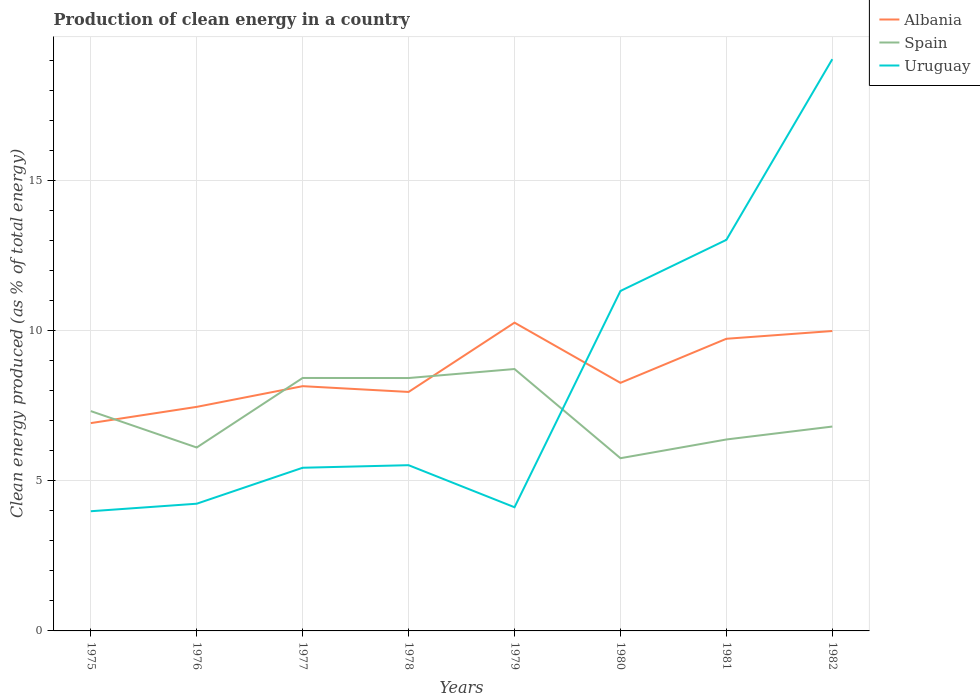How many different coloured lines are there?
Make the answer very short. 3. Does the line corresponding to Uruguay intersect with the line corresponding to Spain?
Offer a very short reply. Yes. Across all years, what is the maximum percentage of clean energy produced in Albania?
Give a very brief answer. 6.92. In which year was the percentage of clean energy produced in Uruguay maximum?
Offer a terse response. 1975. What is the total percentage of clean energy produced in Spain in the graph?
Keep it short and to the point. -1.1. What is the difference between the highest and the second highest percentage of clean energy produced in Spain?
Your response must be concise. 2.97. Is the percentage of clean energy produced in Albania strictly greater than the percentage of clean energy produced in Uruguay over the years?
Provide a succinct answer. No. What is the difference between two consecutive major ticks on the Y-axis?
Keep it short and to the point. 5. Are the values on the major ticks of Y-axis written in scientific E-notation?
Offer a very short reply. No. What is the title of the graph?
Offer a terse response. Production of clean energy in a country. Does "Euro area" appear as one of the legend labels in the graph?
Provide a succinct answer. No. What is the label or title of the X-axis?
Keep it short and to the point. Years. What is the label or title of the Y-axis?
Offer a very short reply. Clean energy produced (as % of total energy). What is the Clean energy produced (as % of total energy) of Albania in 1975?
Keep it short and to the point. 6.92. What is the Clean energy produced (as % of total energy) in Spain in 1975?
Provide a succinct answer. 7.32. What is the Clean energy produced (as % of total energy) of Uruguay in 1975?
Make the answer very short. 3.98. What is the Clean energy produced (as % of total energy) in Albania in 1976?
Give a very brief answer. 7.46. What is the Clean energy produced (as % of total energy) of Spain in 1976?
Your answer should be very brief. 6.11. What is the Clean energy produced (as % of total energy) in Uruguay in 1976?
Keep it short and to the point. 4.24. What is the Clean energy produced (as % of total energy) of Albania in 1977?
Your answer should be very brief. 8.15. What is the Clean energy produced (as % of total energy) in Spain in 1977?
Provide a short and direct response. 8.42. What is the Clean energy produced (as % of total energy) of Uruguay in 1977?
Your answer should be very brief. 5.43. What is the Clean energy produced (as % of total energy) of Albania in 1978?
Your answer should be very brief. 7.96. What is the Clean energy produced (as % of total energy) in Spain in 1978?
Provide a succinct answer. 8.42. What is the Clean energy produced (as % of total energy) in Uruguay in 1978?
Provide a succinct answer. 5.52. What is the Clean energy produced (as % of total energy) of Albania in 1979?
Make the answer very short. 10.26. What is the Clean energy produced (as % of total energy) in Spain in 1979?
Provide a short and direct response. 8.72. What is the Clean energy produced (as % of total energy) of Uruguay in 1979?
Your response must be concise. 4.12. What is the Clean energy produced (as % of total energy) of Albania in 1980?
Provide a short and direct response. 8.26. What is the Clean energy produced (as % of total energy) in Spain in 1980?
Your response must be concise. 5.75. What is the Clean energy produced (as % of total energy) in Uruguay in 1980?
Offer a very short reply. 11.32. What is the Clean energy produced (as % of total energy) of Albania in 1981?
Ensure brevity in your answer.  9.73. What is the Clean energy produced (as % of total energy) in Spain in 1981?
Give a very brief answer. 6.37. What is the Clean energy produced (as % of total energy) of Uruguay in 1981?
Offer a terse response. 13.02. What is the Clean energy produced (as % of total energy) of Albania in 1982?
Provide a succinct answer. 9.99. What is the Clean energy produced (as % of total energy) of Spain in 1982?
Your answer should be very brief. 6.8. What is the Clean energy produced (as % of total energy) of Uruguay in 1982?
Provide a short and direct response. 19.04. Across all years, what is the maximum Clean energy produced (as % of total energy) of Albania?
Provide a succinct answer. 10.26. Across all years, what is the maximum Clean energy produced (as % of total energy) in Spain?
Offer a terse response. 8.72. Across all years, what is the maximum Clean energy produced (as % of total energy) of Uruguay?
Offer a very short reply. 19.04. Across all years, what is the minimum Clean energy produced (as % of total energy) of Albania?
Keep it short and to the point. 6.92. Across all years, what is the minimum Clean energy produced (as % of total energy) in Spain?
Make the answer very short. 5.75. Across all years, what is the minimum Clean energy produced (as % of total energy) of Uruguay?
Give a very brief answer. 3.98. What is the total Clean energy produced (as % of total energy) of Albania in the graph?
Provide a short and direct response. 68.72. What is the total Clean energy produced (as % of total energy) of Spain in the graph?
Your response must be concise. 57.92. What is the total Clean energy produced (as % of total energy) in Uruguay in the graph?
Offer a very short reply. 66.66. What is the difference between the Clean energy produced (as % of total energy) in Albania in 1975 and that in 1976?
Make the answer very short. -0.54. What is the difference between the Clean energy produced (as % of total energy) of Spain in 1975 and that in 1976?
Give a very brief answer. 1.21. What is the difference between the Clean energy produced (as % of total energy) in Uruguay in 1975 and that in 1976?
Your answer should be compact. -0.25. What is the difference between the Clean energy produced (as % of total energy) in Albania in 1975 and that in 1977?
Provide a succinct answer. -1.23. What is the difference between the Clean energy produced (as % of total energy) in Spain in 1975 and that in 1977?
Offer a terse response. -1.1. What is the difference between the Clean energy produced (as % of total energy) of Uruguay in 1975 and that in 1977?
Provide a succinct answer. -1.45. What is the difference between the Clean energy produced (as % of total energy) in Albania in 1975 and that in 1978?
Your response must be concise. -1.04. What is the difference between the Clean energy produced (as % of total energy) of Spain in 1975 and that in 1978?
Provide a succinct answer. -1.1. What is the difference between the Clean energy produced (as % of total energy) of Uruguay in 1975 and that in 1978?
Give a very brief answer. -1.53. What is the difference between the Clean energy produced (as % of total energy) of Albania in 1975 and that in 1979?
Give a very brief answer. -3.34. What is the difference between the Clean energy produced (as % of total energy) of Spain in 1975 and that in 1979?
Give a very brief answer. -1.4. What is the difference between the Clean energy produced (as % of total energy) of Uruguay in 1975 and that in 1979?
Your answer should be compact. -0.13. What is the difference between the Clean energy produced (as % of total energy) in Albania in 1975 and that in 1980?
Keep it short and to the point. -1.34. What is the difference between the Clean energy produced (as % of total energy) in Spain in 1975 and that in 1980?
Your response must be concise. 1.57. What is the difference between the Clean energy produced (as % of total energy) of Uruguay in 1975 and that in 1980?
Provide a short and direct response. -7.33. What is the difference between the Clean energy produced (as % of total energy) of Albania in 1975 and that in 1981?
Your response must be concise. -2.81. What is the difference between the Clean energy produced (as % of total energy) in Spain in 1975 and that in 1981?
Offer a very short reply. 0.94. What is the difference between the Clean energy produced (as % of total energy) of Uruguay in 1975 and that in 1981?
Offer a very short reply. -9.04. What is the difference between the Clean energy produced (as % of total energy) in Albania in 1975 and that in 1982?
Your answer should be compact. -3.07. What is the difference between the Clean energy produced (as % of total energy) of Spain in 1975 and that in 1982?
Keep it short and to the point. 0.51. What is the difference between the Clean energy produced (as % of total energy) of Uruguay in 1975 and that in 1982?
Provide a short and direct response. -15.05. What is the difference between the Clean energy produced (as % of total energy) of Albania in 1976 and that in 1977?
Your response must be concise. -0.69. What is the difference between the Clean energy produced (as % of total energy) of Spain in 1976 and that in 1977?
Offer a very short reply. -2.32. What is the difference between the Clean energy produced (as % of total energy) in Uruguay in 1976 and that in 1977?
Give a very brief answer. -1.2. What is the difference between the Clean energy produced (as % of total energy) in Albania in 1976 and that in 1978?
Your answer should be very brief. -0.5. What is the difference between the Clean energy produced (as % of total energy) of Spain in 1976 and that in 1978?
Your answer should be very brief. -2.31. What is the difference between the Clean energy produced (as % of total energy) in Uruguay in 1976 and that in 1978?
Ensure brevity in your answer.  -1.28. What is the difference between the Clean energy produced (as % of total energy) in Albania in 1976 and that in 1979?
Provide a short and direct response. -2.8. What is the difference between the Clean energy produced (as % of total energy) of Spain in 1976 and that in 1979?
Your response must be concise. -2.61. What is the difference between the Clean energy produced (as % of total energy) in Uruguay in 1976 and that in 1979?
Make the answer very short. 0.12. What is the difference between the Clean energy produced (as % of total energy) of Albania in 1976 and that in 1980?
Make the answer very short. -0.8. What is the difference between the Clean energy produced (as % of total energy) in Spain in 1976 and that in 1980?
Make the answer very short. 0.36. What is the difference between the Clean energy produced (as % of total energy) of Uruguay in 1976 and that in 1980?
Your answer should be very brief. -7.08. What is the difference between the Clean energy produced (as % of total energy) of Albania in 1976 and that in 1981?
Make the answer very short. -2.27. What is the difference between the Clean energy produced (as % of total energy) of Spain in 1976 and that in 1981?
Offer a very short reply. -0.27. What is the difference between the Clean energy produced (as % of total energy) in Uruguay in 1976 and that in 1981?
Provide a succinct answer. -8.78. What is the difference between the Clean energy produced (as % of total energy) of Albania in 1976 and that in 1982?
Your response must be concise. -2.53. What is the difference between the Clean energy produced (as % of total energy) in Spain in 1976 and that in 1982?
Give a very brief answer. -0.7. What is the difference between the Clean energy produced (as % of total energy) in Uruguay in 1976 and that in 1982?
Your answer should be very brief. -14.8. What is the difference between the Clean energy produced (as % of total energy) in Albania in 1977 and that in 1978?
Your answer should be compact. 0.19. What is the difference between the Clean energy produced (as % of total energy) of Spain in 1977 and that in 1978?
Offer a terse response. 0. What is the difference between the Clean energy produced (as % of total energy) of Uruguay in 1977 and that in 1978?
Provide a short and direct response. -0.09. What is the difference between the Clean energy produced (as % of total energy) of Albania in 1977 and that in 1979?
Provide a succinct answer. -2.12. What is the difference between the Clean energy produced (as % of total energy) in Spain in 1977 and that in 1979?
Offer a very short reply. -0.3. What is the difference between the Clean energy produced (as % of total energy) of Uruguay in 1977 and that in 1979?
Keep it short and to the point. 1.31. What is the difference between the Clean energy produced (as % of total energy) in Albania in 1977 and that in 1980?
Give a very brief answer. -0.11. What is the difference between the Clean energy produced (as % of total energy) in Spain in 1977 and that in 1980?
Offer a terse response. 2.67. What is the difference between the Clean energy produced (as % of total energy) in Uruguay in 1977 and that in 1980?
Make the answer very short. -5.89. What is the difference between the Clean energy produced (as % of total energy) of Albania in 1977 and that in 1981?
Keep it short and to the point. -1.58. What is the difference between the Clean energy produced (as % of total energy) of Spain in 1977 and that in 1981?
Keep it short and to the point. 2.05. What is the difference between the Clean energy produced (as % of total energy) of Uruguay in 1977 and that in 1981?
Keep it short and to the point. -7.59. What is the difference between the Clean energy produced (as % of total energy) of Albania in 1977 and that in 1982?
Offer a very short reply. -1.84. What is the difference between the Clean energy produced (as % of total energy) of Spain in 1977 and that in 1982?
Make the answer very short. 1.62. What is the difference between the Clean energy produced (as % of total energy) in Uruguay in 1977 and that in 1982?
Your answer should be compact. -13.6. What is the difference between the Clean energy produced (as % of total energy) in Albania in 1978 and that in 1979?
Your response must be concise. -2.31. What is the difference between the Clean energy produced (as % of total energy) in Spain in 1978 and that in 1979?
Your answer should be compact. -0.3. What is the difference between the Clean energy produced (as % of total energy) in Uruguay in 1978 and that in 1979?
Your answer should be very brief. 1.4. What is the difference between the Clean energy produced (as % of total energy) of Albania in 1978 and that in 1980?
Give a very brief answer. -0.3. What is the difference between the Clean energy produced (as % of total energy) in Spain in 1978 and that in 1980?
Provide a short and direct response. 2.67. What is the difference between the Clean energy produced (as % of total energy) of Uruguay in 1978 and that in 1980?
Provide a succinct answer. -5.8. What is the difference between the Clean energy produced (as % of total energy) in Albania in 1978 and that in 1981?
Keep it short and to the point. -1.77. What is the difference between the Clean energy produced (as % of total energy) in Spain in 1978 and that in 1981?
Offer a terse response. 2.05. What is the difference between the Clean energy produced (as % of total energy) of Uruguay in 1978 and that in 1981?
Give a very brief answer. -7.5. What is the difference between the Clean energy produced (as % of total energy) of Albania in 1978 and that in 1982?
Offer a terse response. -2.03. What is the difference between the Clean energy produced (as % of total energy) in Spain in 1978 and that in 1982?
Your answer should be compact. 1.62. What is the difference between the Clean energy produced (as % of total energy) in Uruguay in 1978 and that in 1982?
Offer a terse response. -13.52. What is the difference between the Clean energy produced (as % of total energy) in Albania in 1979 and that in 1980?
Offer a very short reply. 2. What is the difference between the Clean energy produced (as % of total energy) in Spain in 1979 and that in 1980?
Your answer should be very brief. 2.97. What is the difference between the Clean energy produced (as % of total energy) of Uruguay in 1979 and that in 1980?
Offer a terse response. -7.2. What is the difference between the Clean energy produced (as % of total energy) in Albania in 1979 and that in 1981?
Keep it short and to the point. 0.54. What is the difference between the Clean energy produced (as % of total energy) of Spain in 1979 and that in 1981?
Provide a succinct answer. 2.35. What is the difference between the Clean energy produced (as % of total energy) in Uruguay in 1979 and that in 1981?
Your answer should be compact. -8.9. What is the difference between the Clean energy produced (as % of total energy) of Albania in 1979 and that in 1982?
Your answer should be compact. 0.28. What is the difference between the Clean energy produced (as % of total energy) of Spain in 1979 and that in 1982?
Offer a very short reply. 1.92. What is the difference between the Clean energy produced (as % of total energy) of Uruguay in 1979 and that in 1982?
Your answer should be compact. -14.92. What is the difference between the Clean energy produced (as % of total energy) of Albania in 1980 and that in 1981?
Offer a very short reply. -1.47. What is the difference between the Clean energy produced (as % of total energy) of Spain in 1980 and that in 1981?
Your response must be concise. -0.62. What is the difference between the Clean energy produced (as % of total energy) of Uruguay in 1980 and that in 1981?
Offer a very short reply. -1.7. What is the difference between the Clean energy produced (as % of total energy) in Albania in 1980 and that in 1982?
Keep it short and to the point. -1.73. What is the difference between the Clean energy produced (as % of total energy) of Spain in 1980 and that in 1982?
Keep it short and to the point. -1.05. What is the difference between the Clean energy produced (as % of total energy) in Uruguay in 1980 and that in 1982?
Provide a succinct answer. -7.72. What is the difference between the Clean energy produced (as % of total energy) in Albania in 1981 and that in 1982?
Make the answer very short. -0.26. What is the difference between the Clean energy produced (as % of total energy) of Spain in 1981 and that in 1982?
Make the answer very short. -0.43. What is the difference between the Clean energy produced (as % of total energy) of Uruguay in 1981 and that in 1982?
Provide a short and direct response. -6.02. What is the difference between the Clean energy produced (as % of total energy) in Albania in 1975 and the Clean energy produced (as % of total energy) in Spain in 1976?
Keep it short and to the point. 0.81. What is the difference between the Clean energy produced (as % of total energy) in Albania in 1975 and the Clean energy produced (as % of total energy) in Uruguay in 1976?
Your answer should be very brief. 2.68. What is the difference between the Clean energy produced (as % of total energy) of Spain in 1975 and the Clean energy produced (as % of total energy) of Uruguay in 1976?
Keep it short and to the point. 3.08. What is the difference between the Clean energy produced (as % of total energy) in Albania in 1975 and the Clean energy produced (as % of total energy) in Spain in 1977?
Give a very brief answer. -1.5. What is the difference between the Clean energy produced (as % of total energy) of Albania in 1975 and the Clean energy produced (as % of total energy) of Uruguay in 1977?
Ensure brevity in your answer.  1.49. What is the difference between the Clean energy produced (as % of total energy) in Spain in 1975 and the Clean energy produced (as % of total energy) in Uruguay in 1977?
Offer a terse response. 1.89. What is the difference between the Clean energy produced (as % of total energy) in Albania in 1975 and the Clean energy produced (as % of total energy) in Spain in 1978?
Your answer should be compact. -1.5. What is the difference between the Clean energy produced (as % of total energy) in Albania in 1975 and the Clean energy produced (as % of total energy) in Uruguay in 1978?
Offer a very short reply. 1.4. What is the difference between the Clean energy produced (as % of total energy) in Spain in 1975 and the Clean energy produced (as % of total energy) in Uruguay in 1978?
Offer a terse response. 1.8. What is the difference between the Clean energy produced (as % of total energy) in Albania in 1975 and the Clean energy produced (as % of total energy) in Spain in 1979?
Make the answer very short. -1.8. What is the difference between the Clean energy produced (as % of total energy) of Albania in 1975 and the Clean energy produced (as % of total energy) of Uruguay in 1979?
Ensure brevity in your answer.  2.8. What is the difference between the Clean energy produced (as % of total energy) in Spain in 1975 and the Clean energy produced (as % of total energy) in Uruguay in 1979?
Your answer should be compact. 3.2. What is the difference between the Clean energy produced (as % of total energy) of Albania in 1975 and the Clean energy produced (as % of total energy) of Spain in 1980?
Your answer should be compact. 1.17. What is the difference between the Clean energy produced (as % of total energy) of Albania in 1975 and the Clean energy produced (as % of total energy) of Uruguay in 1980?
Give a very brief answer. -4.4. What is the difference between the Clean energy produced (as % of total energy) in Spain in 1975 and the Clean energy produced (as % of total energy) in Uruguay in 1980?
Offer a very short reply. -4. What is the difference between the Clean energy produced (as % of total energy) in Albania in 1975 and the Clean energy produced (as % of total energy) in Spain in 1981?
Offer a terse response. 0.55. What is the difference between the Clean energy produced (as % of total energy) of Albania in 1975 and the Clean energy produced (as % of total energy) of Uruguay in 1981?
Your answer should be very brief. -6.1. What is the difference between the Clean energy produced (as % of total energy) in Spain in 1975 and the Clean energy produced (as % of total energy) in Uruguay in 1981?
Offer a terse response. -5.7. What is the difference between the Clean energy produced (as % of total energy) in Albania in 1975 and the Clean energy produced (as % of total energy) in Spain in 1982?
Your answer should be very brief. 0.11. What is the difference between the Clean energy produced (as % of total energy) of Albania in 1975 and the Clean energy produced (as % of total energy) of Uruguay in 1982?
Your answer should be compact. -12.12. What is the difference between the Clean energy produced (as % of total energy) in Spain in 1975 and the Clean energy produced (as % of total energy) in Uruguay in 1982?
Provide a succinct answer. -11.72. What is the difference between the Clean energy produced (as % of total energy) in Albania in 1976 and the Clean energy produced (as % of total energy) in Spain in 1977?
Give a very brief answer. -0.96. What is the difference between the Clean energy produced (as % of total energy) in Albania in 1976 and the Clean energy produced (as % of total energy) in Uruguay in 1977?
Offer a very short reply. 2.03. What is the difference between the Clean energy produced (as % of total energy) in Spain in 1976 and the Clean energy produced (as % of total energy) in Uruguay in 1977?
Offer a very short reply. 0.67. What is the difference between the Clean energy produced (as % of total energy) in Albania in 1976 and the Clean energy produced (as % of total energy) in Spain in 1978?
Offer a very short reply. -0.96. What is the difference between the Clean energy produced (as % of total energy) in Albania in 1976 and the Clean energy produced (as % of total energy) in Uruguay in 1978?
Your answer should be very brief. 1.94. What is the difference between the Clean energy produced (as % of total energy) in Spain in 1976 and the Clean energy produced (as % of total energy) in Uruguay in 1978?
Keep it short and to the point. 0.59. What is the difference between the Clean energy produced (as % of total energy) in Albania in 1976 and the Clean energy produced (as % of total energy) in Spain in 1979?
Give a very brief answer. -1.26. What is the difference between the Clean energy produced (as % of total energy) in Albania in 1976 and the Clean energy produced (as % of total energy) in Uruguay in 1979?
Make the answer very short. 3.34. What is the difference between the Clean energy produced (as % of total energy) of Spain in 1976 and the Clean energy produced (as % of total energy) of Uruguay in 1979?
Provide a succinct answer. 1.99. What is the difference between the Clean energy produced (as % of total energy) in Albania in 1976 and the Clean energy produced (as % of total energy) in Spain in 1980?
Your answer should be very brief. 1.71. What is the difference between the Clean energy produced (as % of total energy) of Albania in 1976 and the Clean energy produced (as % of total energy) of Uruguay in 1980?
Your answer should be very brief. -3.86. What is the difference between the Clean energy produced (as % of total energy) in Spain in 1976 and the Clean energy produced (as % of total energy) in Uruguay in 1980?
Offer a terse response. -5.21. What is the difference between the Clean energy produced (as % of total energy) in Albania in 1976 and the Clean energy produced (as % of total energy) in Spain in 1981?
Keep it short and to the point. 1.09. What is the difference between the Clean energy produced (as % of total energy) in Albania in 1976 and the Clean energy produced (as % of total energy) in Uruguay in 1981?
Provide a succinct answer. -5.56. What is the difference between the Clean energy produced (as % of total energy) of Spain in 1976 and the Clean energy produced (as % of total energy) of Uruguay in 1981?
Provide a succinct answer. -6.91. What is the difference between the Clean energy produced (as % of total energy) in Albania in 1976 and the Clean energy produced (as % of total energy) in Spain in 1982?
Give a very brief answer. 0.66. What is the difference between the Clean energy produced (as % of total energy) in Albania in 1976 and the Clean energy produced (as % of total energy) in Uruguay in 1982?
Your answer should be compact. -11.58. What is the difference between the Clean energy produced (as % of total energy) of Spain in 1976 and the Clean energy produced (as % of total energy) of Uruguay in 1982?
Ensure brevity in your answer.  -12.93. What is the difference between the Clean energy produced (as % of total energy) in Albania in 1977 and the Clean energy produced (as % of total energy) in Spain in 1978?
Provide a succinct answer. -0.27. What is the difference between the Clean energy produced (as % of total energy) in Albania in 1977 and the Clean energy produced (as % of total energy) in Uruguay in 1978?
Provide a succinct answer. 2.63. What is the difference between the Clean energy produced (as % of total energy) in Spain in 1977 and the Clean energy produced (as % of total energy) in Uruguay in 1978?
Ensure brevity in your answer.  2.9. What is the difference between the Clean energy produced (as % of total energy) of Albania in 1977 and the Clean energy produced (as % of total energy) of Spain in 1979?
Keep it short and to the point. -0.57. What is the difference between the Clean energy produced (as % of total energy) in Albania in 1977 and the Clean energy produced (as % of total energy) in Uruguay in 1979?
Your answer should be compact. 4.03. What is the difference between the Clean energy produced (as % of total energy) in Spain in 1977 and the Clean energy produced (as % of total energy) in Uruguay in 1979?
Your answer should be very brief. 4.3. What is the difference between the Clean energy produced (as % of total energy) in Albania in 1977 and the Clean energy produced (as % of total energy) in Spain in 1980?
Offer a very short reply. 2.4. What is the difference between the Clean energy produced (as % of total energy) of Albania in 1977 and the Clean energy produced (as % of total energy) of Uruguay in 1980?
Keep it short and to the point. -3.17. What is the difference between the Clean energy produced (as % of total energy) of Spain in 1977 and the Clean energy produced (as % of total energy) of Uruguay in 1980?
Your answer should be very brief. -2.9. What is the difference between the Clean energy produced (as % of total energy) of Albania in 1977 and the Clean energy produced (as % of total energy) of Spain in 1981?
Provide a short and direct response. 1.77. What is the difference between the Clean energy produced (as % of total energy) in Albania in 1977 and the Clean energy produced (as % of total energy) in Uruguay in 1981?
Keep it short and to the point. -4.87. What is the difference between the Clean energy produced (as % of total energy) of Spain in 1977 and the Clean energy produced (as % of total energy) of Uruguay in 1981?
Provide a short and direct response. -4.6. What is the difference between the Clean energy produced (as % of total energy) in Albania in 1977 and the Clean energy produced (as % of total energy) in Spain in 1982?
Offer a very short reply. 1.34. What is the difference between the Clean energy produced (as % of total energy) in Albania in 1977 and the Clean energy produced (as % of total energy) in Uruguay in 1982?
Offer a terse response. -10.89. What is the difference between the Clean energy produced (as % of total energy) in Spain in 1977 and the Clean energy produced (as % of total energy) in Uruguay in 1982?
Your answer should be compact. -10.61. What is the difference between the Clean energy produced (as % of total energy) in Albania in 1978 and the Clean energy produced (as % of total energy) in Spain in 1979?
Provide a succinct answer. -0.76. What is the difference between the Clean energy produced (as % of total energy) in Albania in 1978 and the Clean energy produced (as % of total energy) in Uruguay in 1979?
Keep it short and to the point. 3.84. What is the difference between the Clean energy produced (as % of total energy) of Spain in 1978 and the Clean energy produced (as % of total energy) of Uruguay in 1979?
Provide a short and direct response. 4.3. What is the difference between the Clean energy produced (as % of total energy) in Albania in 1978 and the Clean energy produced (as % of total energy) in Spain in 1980?
Your response must be concise. 2.21. What is the difference between the Clean energy produced (as % of total energy) of Albania in 1978 and the Clean energy produced (as % of total energy) of Uruguay in 1980?
Make the answer very short. -3.36. What is the difference between the Clean energy produced (as % of total energy) of Spain in 1978 and the Clean energy produced (as % of total energy) of Uruguay in 1980?
Offer a terse response. -2.9. What is the difference between the Clean energy produced (as % of total energy) of Albania in 1978 and the Clean energy produced (as % of total energy) of Spain in 1981?
Offer a very short reply. 1.58. What is the difference between the Clean energy produced (as % of total energy) in Albania in 1978 and the Clean energy produced (as % of total energy) in Uruguay in 1981?
Keep it short and to the point. -5.06. What is the difference between the Clean energy produced (as % of total energy) in Spain in 1978 and the Clean energy produced (as % of total energy) in Uruguay in 1981?
Your answer should be compact. -4.6. What is the difference between the Clean energy produced (as % of total energy) of Albania in 1978 and the Clean energy produced (as % of total energy) of Spain in 1982?
Provide a succinct answer. 1.15. What is the difference between the Clean energy produced (as % of total energy) in Albania in 1978 and the Clean energy produced (as % of total energy) in Uruguay in 1982?
Give a very brief answer. -11.08. What is the difference between the Clean energy produced (as % of total energy) of Spain in 1978 and the Clean energy produced (as % of total energy) of Uruguay in 1982?
Keep it short and to the point. -10.62. What is the difference between the Clean energy produced (as % of total energy) of Albania in 1979 and the Clean energy produced (as % of total energy) of Spain in 1980?
Your response must be concise. 4.51. What is the difference between the Clean energy produced (as % of total energy) of Albania in 1979 and the Clean energy produced (as % of total energy) of Uruguay in 1980?
Offer a very short reply. -1.06. What is the difference between the Clean energy produced (as % of total energy) of Spain in 1979 and the Clean energy produced (as % of total energy) of Uruguay in 1980?
Provide a short and direct response. -2.6. What is the difference between the Clean energy produced (as % of total energy) in Albania in 1979 and the Clean energy produced (as % of total energy) in Spain in 1981?
Offer a terse response. 3.89. What is the difference between the Clean energy produced (as % of total energy) of Albania in 1979 and the Clean energy produced (as % of total energy) of Uruguay in 1981?
Your response must be concise. -2.76. What is the difference between the Clean energy produced (as % of total energy) in Spain in 1979 and the Clean energy produced (as % of total energy) in Uruguay in 1981?
Your answer should be compact. -4.3. What is the difference between the Clean energy produced (as % of total energy) of Albania in 1979 and the Clean energy produced (as % of total energy) of Spain in 1982?
Your response must be concise. 3.46. What is the difference between the Clean energy produced (as % of total energy) of Albania in 1979 and the Clean energy produced (as % of total energy) of Uruguay in 1982?
Offer a terse response. -8.77. What is the difference between the Clean energy produced (as % of total energy) in Spain in 1979 and the Clean energy produced (as % of total energy) in Uruguay in 1982?
Your answer should be compact. -10.32. What is the difference between the Clean energy produced (as % of total energy) in Albania in 1980 and the Clean energy produced (as % of total energy) in Spain in 1981?
Offer a very short reply. 1.89. What is the difference between the Clean energy produced (as % of total energy) of Albania in 1980 and the Clean energy produced (as % of total energy) of Uruguay in 1981?
Keep it short and to the point. -4.76. What is the difference between the Clean energy produced (as % of total energy) in Spain in 1980 and the Clean energy produced (as % of total energy) in Uruguay in 1981?
Keep it short and to the point. -7.27. What is the difference between the Clean energy produced (as % of total energy) in Albania in 1980 and the Clean energy produced (as % of total energy) in Spain in 1982?
Give a very brief answer. 1.46. What is the difference between the Clean energy produced (as % of total energy) in Albania in 1980 and the Clean energy produced (as % of total energy) in Uruguay in 1982?
Your answer should be compact. -10.78. What is the difference between the Clean energy produced (as % of total energy) in Spain in 1980 and the Clean energy produced (as % of total energy) in Uruguay in 1982?
Your answer should be compact. -13.29. What is the difference between the Clean energy produced (as % of total energy) in Albania in 1981 and the Clean energy produced (as % of total energy) in Spain in 1982?
Your response must be concise. 2.92. What is the difference between the Clean energy produced (as % of total energy) of Albania in 1981 and the Clean energy produced (as % of total energy) of Uruguay in 1982?
Make the answer very short. -9.31. What is the difference between the Clean energy produced (as % of total energy) in Spain in 1981 and the Clean energy produced (as % of total energy) in Uruguay in 1982?
Offer a very short reply. -12.66. What is the average Clean energy produced (as % of total energy) of Albania per year?
Offer a terse response. 8.59. What is the average Clean energy produced (as % of total energy) in Spain per year?
Keep it short and to the point. 7.24. What is the average Clean energy produced (as % of total energy) in Uruguay per year?
Your answer should be compact. 8.33. In the year 1975, what is the difference between the Clean energy produced (as % of total energy) in Albania and Clean energy produced (as % of total energy) in Spain?
Offer a terse response. -0.4. In the year 1975, what is the difference between the Clean energy produced (as % of total energy) in Albania and Clean energy produced (as % of total energy) in Uruguay?
Ensure brevity in your answer.  2.93. In the year 1975, what is the difference between the Clean energy produced (as % of total energy) of Spain and Clean energy produced (as % of total energy) of Uruguay?
Give a very brief answer. 3.33. In the year 1976, what is the difference between the Clean energy produced (as % of total energy) in Albania and Clean energy produced (as % of total energy) in Spain?
Offer a terse response. 1.35. In the year 1976, what is the difference between the Clean energy produced (as % of total energy) in Albania and Clean energy produced (as % of total energy) in Uruguay?
Offer a terse response. 3.22. In the year 1976, what is the difference between the Clean energy produced (as % of total energy) in Spain and Clean energy produced (as % of total energy) in Uruguay?
Ensure brevity in your answer.  1.87. In the year 1977, what is the difference between the Clean energy produced (as % of total energy) of Albania and Clean energy produced (as % of total energy) of Spain?
Your answer should be very brief. -0.27. In the year 1977, what is the difference between the Clean energy produced (as % of total energy) of Albania and Clean energy produced (as % of total energy) of Uruguay?
Your answer should be very brief. 2.72. In the year 1977, what is the difference between the Clean energy produced (as % of total energy) of Spain and Clean energy produced (as % of total energy) of Uruguay?
Offer a terse response. 2.99. In the year 1978, what is the difference between the Clean energy produced (as % of total energy) of Albania and Clean energy produced (as % of total energy) of Spain?
Make the answer very short. -0.46. In the year 1978, what is the difference between the Clean energy produced (as % of total energy) of Albania and Clean energy produced (as % of total energy) of Uruguay?
Provide a short and direct response. 2.44. In the year 1978, what is the difference between the Clean energy produced (as % of total energy) in Spain and Clean energy produced (as % of total energy) in Uruguay?
Keep it short and to the point. 2.9. In the year 1979, what is the difference between the Clean energy produced (as % of total energy) of Albania and Clean energy produced (as % of total energy) of Spain?
Offer a very short reply. 1.54. In the year 1979, what is the difference between the Clean energy produced (as % of total energy) in Albania and Clean energy produced (as % of total energy) in Uruguay?
Keep it short and to the point. 6.15. In the year 1979, what is the difference between the Clean energy produced (as % of total energy) of Spain and Clean energy produced (as % of total energy) of Uruguay?
Keep it short and to the point. 4.6. In the year 1980, what is the difference between the Clean energy produced (as % of total energy) in Albania and Clean energy produced (as % of total energy) in Spain?
Make the answer very short. 2.51. In the year 1980, what is the difference between the Clean energy produced (as % of total energy) of Albania and Clean energy produced (as % of total energy) of Uruguay?
Offer a terse response. -3.06. In the year 1980, what is the difference between the Clean energy produced (as % of total energy) in Spain and Clean energy produced (as % of total energy) in Uruguay?
Make the answer very short. -5.57. In the year 1981, what is the difference between the Clean energy produced (as % of total energy) of Albania and Clean energy produced (as % of total energy) of Spain?
Ensure brevity in your answer.  3.35. In the year 1981, what is the difference between the Clean energy produced (as % of total energy) of Albania and Clean energy produced (as % of total energy) of Uruguay?
Your answer should be very brief. -3.29. In the year 1981, what is the difference between the Clean energy produced (as % of total energy) of Spain and Clean energy produced (as % of total energy) of Uruguay?
Offer a very short reply. -6.65. In the year 1982, what is the difference between the Clean energy produced (as % of total energy) in Albania and Clean energy produced (as % of total energy) in Spain?
Offer a very short reply. 3.18. In the year 1982, what is the difference between the Clean energy produced (as % of total energy) in Albania and Clean energy produced (as % of total energy) in Uruguay?
Provide a succinct answer. -9.05. In the year 1982, what is the difference between the Clean energy produced (as % of total energy) of Spain and Clean energy produced (as % of total energy) of Uruguay?
Offer a very short reply. -12.23. What is the ratio of the Clean energy produced (as % of total energy) in Albania in 1975 to that in 1976?
Keep it short and to the point. 0.93. What is the ratio of the Clean energy produced (as % of total energy) in Spain in 1975 to that in 1976?
Make the answer very short. 1.2. What is the ratio of the Clean energy produced (as % of total energy) in Uruguay in 1975 to that in 1976?
Your answer should be compact. 0.94. What is the ratio of the Clean energy produced (as % of total energy) in Albania in 1975 to that in 1977?
Give a very brief answer. 0.85. What is the ratio of the Clean energy produced (as % of total energy) of Spain in 1975 to that in 1977?
Give a very brief answer. 0.87. What is the ratio of the Clean energy produced (as % of total energy) in Uruguay in 1975 to that in 1977?
Offer a terse response. 0.73. What is the ratio of the Clean energy produced (as % of total energy) in Albania in 1975 to that in 1978?
Your answer should be compact. 0.87. What is the ratio of the Clean energy produced (as % of total energy) in Spain in 1975 to that in 1978?
Ensure brevity in your answer.  0.87. What is the ratio of the Clean energy produced (as % of total energy) of Uruguay in 1975 to that in 1978?
Your answer should be very brief. 0.72. What is the ratio of the Clean energy produced (as % of total energy) in Albania in 1975 to that in 1979?
Provide a succinct answer. 0.67. What is the ratio of the Clean energy produced (as % of total energy) of Spain in 1975 to that in 1979?
Your response must be concise. 0.84. What is the ratio of the Clean energy produced (as % of total energy) of Uruguay in 1975 to that in 1979?
Offer a very short reply. 0.97. What is the ratio of the Clean energy produced (as % of total energy) in Albania in 1975 to that in 1980?
Your answer should be very brief. 0.84. What is the ratio of the Clean energy produced (as % of total energy) in Spain in 1975 to that in 1980?
Ensure brevity in your answer.  1.27. What is the ratio of the Clean energy produced (as % of total energy) in Uruguay in 1975 to that in 1980?
Offer a very short reply. 0.35. What is the ratio of the Clean energy produced (as % of total energy) of Albania in 1975 to that in 1981?
Offer a terse response. 0.71. What is the ratio of the Clean energy produced (as % of total energy) in Spain in 1975 to that in 1981?
Make the answer very short. 1.15. What is the ratio of the Clean energy produced (as % of total energy) of Uruguay in 1975 to that in 1981?
Make the answer very short. 0.31. What is the ratio of the Clean energy produced (as % of total energy) in Albania in 1975 to that in 1982?
Give a very brief answer. 0.69. What is the ratio of the Clean energy produced (as % of total energy) in Spain in 1975 to that in 1982?
Provide a short and direct response. 1.08. What is the ratio of the Clean energy produced (as % of total energy) of Uruguay in 1975 to that in 1982?
Your response must be concise. 0.21. What is the ratio of the Clean energy produced (as % of total energy) in Albania in 1976 to that in 1977?
Your answer should be very brief. 0.92. What is the ratio of the Clean energy produced (as % of total energy) of Spain in 1976 to that in 1977?
Give a very brief answer. 0.73. What is the ratio of the Clean energy produced (as % of total energy) of Uruguay in 1976 to that in 1977?
Ensure brevity in your answer.  0.78. What is the ratio of the Clean energy produced (as % of total energy) in Spain in 1976 to that in 1978?
Your answer should be very brief. 0.73. What is the ratio of the Clean energy produced (as % of total energy) in Uruguay in 1976 to that in 1978?
Your answer should be very brief. 0.77. What is the ratio of the Clean energy produced (as % of total energy) of Albania in 1976 to that in 1979?
Offer a very short reply. 0.73. What is the ratio of the Clean energy produced (as % of total energy) in Spain in 1976 to that in 1979?
Your response must be concise. 0.7. What is the ratio of the Clean energy produced (as % of total energy) in Uruguay in 1976 to that in 1979?
Your answer should be compact. 1.03. What is the ratio of the Clean energy produced (as % of total energy) in Albania in 1976 to that in 1980?
Provide a succinct answer. 0.9. What is the ratio of the Clean energy produced (as % of total energy) in Spain in 1976 to that in 1980?
Ensure brevity in your answer.  1.06. What is the ratio of the Clean energy produced (as % of total energy) in Uruguay in 1976 to that in 1980?
Your answer should be very brief. 0.37. What is the ratio of the Clean energy produced (as % of total energy) in Albania in 1976 to that in 1981?
Keep it short and to the point. 0.77. What is the ratio of the Clean energy produced (as % of total energy) in Spain in 1976 to that in 1981?
Offer a very short reply. 0.96. What is the ratio of the Clean energy produced (as % of total energy) of Uruguay in 1976 to that in 1981?
Offer a very short reply. 0.33. What is the ratio of the Clean energy produced (as % of total energy) in Albania in 1976 to that in 1982?
Your answer should be very brief. 0.75. What is the ratio of the Clean energy produced (as % of total energy) in Spain in 1976 to that in 1982?
Your response must be concise. 0.9. What is the ratio of the Clean energy produced (as % of total energy) of Uruguay in 1976 to that in 1982?
Make the answer very short. 0.22. What is the ratio of the Clean energy produced (as % of total energy) in Albania in 1977 to that in 1978?
Offer a terse response. 1.02. What is the ratio of the Clean energy produced (as % of total energy) of Uruguay in 1977 to that in 1978?
Provide a succinct answer. 0.98. What is the ratio of the Clean energy produced (as % of total energy) of Albania in 1977 to that in 1979?
Ensure brevity in your answer.  0.79. What is the ratio of the Clean energy produced (as % of total energy) of Spain in 1977 to that in 1979?
Offer a very short reply. 0.97. What is the ratio of the Clean energy produced (as % of total energy) of Uruguay in 1977 to that in 1979?
Make the answer very short. 1.32. What is the ratio of the Clean energy produced (as % of total energy) in Albania in 1977 to that in 1980?
Your answer should be very brief. 0.99. What is the ratio of the Clean energy produced (as % of total energy) of Spain in 1977 to that in 1980?
Give a very brief answer. 1.46. What is the ratio of the Clean energy produced (as % of total energy) in Uruguay in 1977 to that in 1980?
Make the answer very short. 0.48. What is the ratio of the Clean energy produced (as % of total energy) in Albania in 1977 to that in 1981?
Provide a short and direct response. 0.84. What is the ratio of the Clean energy produced (as % of total energy) of Spain in 1977 to that in 1981?
Your response must be concise. 1.32. What is the ratio of the Clean energy produced (as % of total energy) of Uruguay in 1977 to that in 1981?
Your response must be concise. 0.42. What is the ratio of the Clean energy produced (as % of total energy) in Albania in 1977 to that in 1982?
Your answer should be compact. 0.82. What is the ratio of the Clean energy produced (as % of total energy) in Spain in 1977 to that in 1982?
Offer a very short reply. 1.24. What is the ratio of the Clean energy produced (as % of total energy) of Uruguay in 1977 to that in 1982?
Provide a short and direct response. 0.29. What is the ratio of the Clean energy produced (as % of total energy) in Albania in 1978 to that in 1979?
Your answer should be compact. 0.78. What is the ratio of the Clean energy produced (as % of total energy) of Spain in 1978 to that in 1979?
Your answer should be very brief. 0.97. What is the ratio of the Clean energy produced (as % of total energy) in Uruguay in 1978 to that in 1979?
Your response must be concise. 1.34. What is the ratio of the Clean energy produced (as % of total energy) of Albania in 1978 to that in 1980?
Give a very brief answer. 0.96. What is the ratio of the Clean energy produced (as % of total energy) of Spain in 1978 to that in 1980?
Your answer should be compact. 1.46. What is the ratio of the Clean energy produced (as % of total energy) in Uruguay in 1978 to that in 1980?
Give a very brief answer. 0.49. What is the ratio of the Clean energy produced (as % of total energy) in Albania in 1978 to that in 1981?
Make the answer very short. 0.82. What is the ratio of the Clean energy produced (as % of total energy) of Spain in 1978 to that in 1981?
Offer a terse response. 1.32. What is the ratio of the Clean energy produced (as % of total energy) in Uruguay in 1978 to that in 1981?
Keep it short and to the point. 0.42. What is the ratio of the Clean energy produced (as % of total energy) of Albania in 1978 to that in 1982?
Make the answer very short. 0.8. What is the ratio of the Clean energy produced (as % of total energy) of Spain in 1978 to that in 1982?
Provide a succinct answer. 1.24. What is the ratio of the Clean energy produced (as % of total energy) of Uruguay in 1978 to that in 1982?
Ensure brevity in your answer.  0.29. What is the ratio of the Clean energy produced (as % of total energy) in Albania in 1979 to that in 1980?
Give a very brief answer. 1.24. What is the ratio of the Clean energy produced (as % of total energy) of Spain in 1979 to that in 1980?
Offer a terse response. 1.52. What is the ratio of the Clean energy produced (as % of total energy) of Uruguay in 1979 to that in 1980?
Your answer should be very brief. 0.36. What is the ratio of the Clean energy produced (as % of total energy) in Albania in 1979 to that in 1981?
Make the answer very short. 1.06. What is the ratio of the Clean energy produced (as % of total energy) of Spain in 1979 to that in 1981?
Make the answer very short. 1.37. What is the ratio of the Clean energy produced (as % of total energy) in Uruguay in 1979 to that in 1981?
Offer a very short reply. 0.32. What is the ratio of the Clean energy produced (as % of total energy) of Albania in 1979 to that in 1982?
Give a very brief answer. 1.03. What is the ratio of the Clean energy produced (as % of total energy) of Spain in 1979 to that in 1982?
Keep it short and to the point. 1.28. What is the ratio of the Clean energy produced (as % of total energy) in Uruguay in 1979 to that in 1982?
Offer a terse response. 0.22. What is the ratio of the Clean energy produced (as % of total energy) in Albania in 1980 to that in 1981?
Provide a succinct answer. 0.85. What is the ratio of the Clean energy produced (as % of total energy) of Spain in 1980 to that in 1981?
Offer a terse response. 0.9. What is the ratio of the Clean energy produced (as % of total energy) of Uruguay in 1980 to that in 1981?
Offer a terse response. 0.87. What is the ratio of the Clean energy produced (as % of total energy) of Albania in 1980 to that in 1982?
Offer a very short reply. 0.83. What is the ratio of the Clean energy produced (as % of total energy) of Spain in 1980 to that in 1982?
Offer a very short reply. 0.85. What is the ratio of the Clean energy produced (as % of total energy) in Uruguay in 1980 to that in 1982?
Give a very brief answer. 0.59. What is the ratio of the Clean energy produced (as % of total energy) of Albania in 1981 to that in 1982?
Offer a very short reply. 0.97. What is the ratio of the Clean energy produced (as % of total energy) in Spain in 1981 to that in 1982?
Ensure brevity in your answer.  0.94. What is the ratio of the Clean energy produced (as % of total energy) of Uruguay in 1981 to that in 1982?
Your answer should be very brief. 0.68. What is the difference between the highest and the second highest Clean energy produced (as % of total energy) of Albania?
Give a very brief answer. 0.28. What is the difference between the highest and the second highest Clean energy produced (as % of total energy) in Spain?
Provide a short and direct response. 0.3. What is the difference between the highest and the second highest Clean energy produced (as % of total energy) of Uruguay?
Offer a very short reply. 6.02. What is the difference between the highest and the lowest Clean energy produced (as % of total energy) of Albania?
Your answer should be very brief. 3.34. What is the difference between the highest and the lowest Clean energy produced (as % of total energy) of Spain?
Provide a short and direct response. 2.97. What is the difference between the highest and the lowest Clean energy produced (as % of total energy) of Uruguay?
Your answer should be very brief. 15.05. 